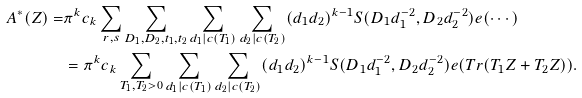Convert formula to latex. <formula><loc_0><loc_0><loc_500><loc_500>A ^ { * } ( Z ) = & \pi ^ { k } c _ { k } \sum _ { r , s } \sum _ { D _ { 1 } , D _ { 2 } , t _ { 1 } , t _ { 2 } } \sum _ { d _ { 1 } | c ( T _ { 1 } ) } \sum _ { d _ { 2 } | c ( T _ { 2 } ) } ( d _ { 1 } d _ { 2 } ) ^ { k - 1 } S ( D _ { 1 } d _ { 1 } ^ { - 2 } , D _ { 2 } d _ { 2 } ^ { - 2 } ) e ( \cdots ) \\ & = \pi ^ { k } c _ { k } \sum _ { T _ { 1 } , T _ { 2 } > 0 } \sum _ { d _ { 1 } | c ( T _ { 1 } ) } \sum _ { d _ { 2 } | c ( T _ { 2 } ) } ( d _ { 1 } d _ { 2 } ) ^ { k - 1 } S ( D _ { 1 } d _ { 1 } ^ { - 2 } , D _ { 2 } d _ { 2 } ^ { - 2 } ) e ( T r ( T _ { 1 } Z + T _ { 2 } Z ) ) .</formula> 